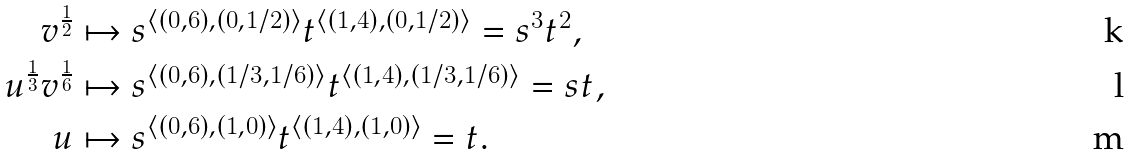<formula> <loc_0><loc_0><loc_500><loc_500>v ^ { \frac { 1 } { 2 } } & \mapsto s ^ { \langle ( 0 , 6 ) , ( 0 , 1 / 2 ) \rangle } t ^ { \langle ( 1 , 4 ) , ( 0 , 1 / 2 ) \rangle } = s ^ { 3 } t ^ { 2 } , \\ u ^ { \frac { 1 } { 3 } } v ^ { \frac { 1 } { 6 } } & \mapsto s ^ { \langle ( 0 , 6 ) , ( 1 / 3 , 1 / 6 ) \rangle } t ^ { \langle ( 1 , 4 ) , ( 1 / 3 , 1 / 6 ) \rangle } = s t , \\ u & \mapsto s ^ { \langle ( 0 , 6 ) , ( 1 , 0 ) \rangle } t ^ { \langle ( 1 , 4 ) , ( 1 , 0 ) \rangle } = t .</formula> 